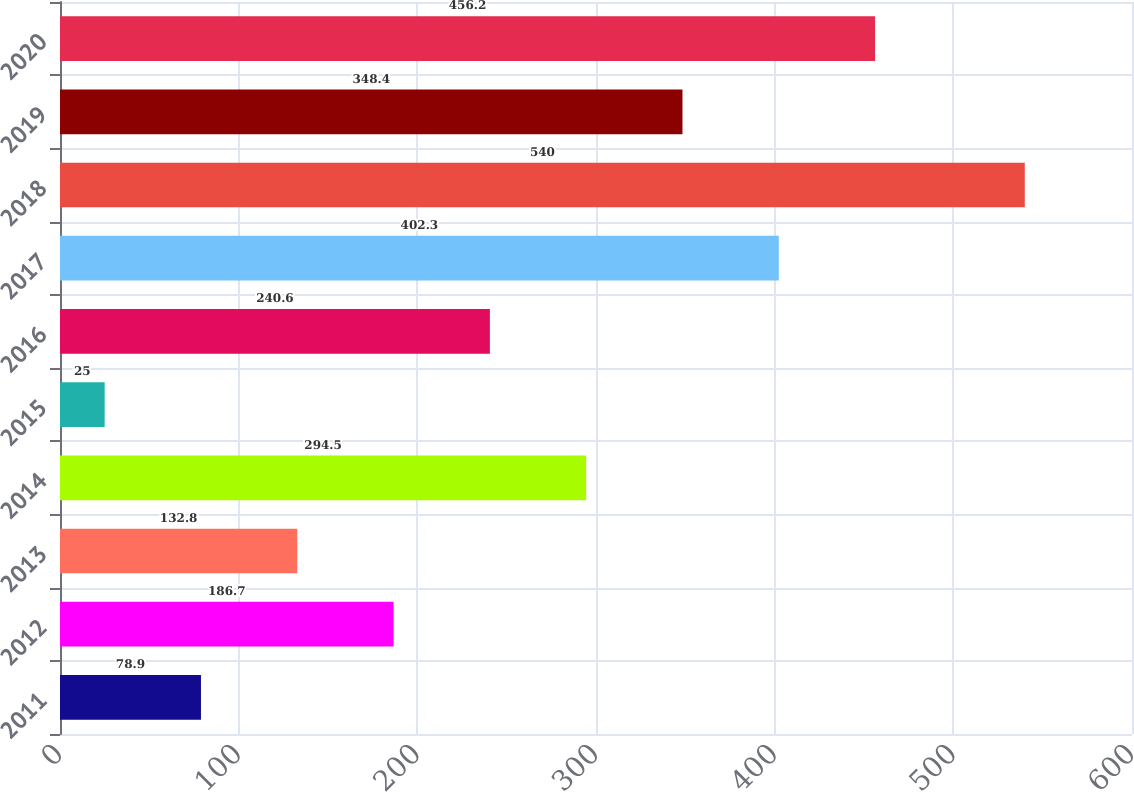<chart> <loc_0><loc_0><loc_500><loc_500><bar_chart><fcel>2011<fcel>2012<fcel>2013<fcel>2014<fcel>2015<fcel>2016<fcel>2017<fcel>2018<fcel>2019<fcel>2020<nl><fcel>78.9<fcel>186.7<fcel>132.8<fcel>294.5<fcel>25<fcel>240.6<fcel>402.3<fcel>540<fcel>348.4<fcel>456.2<nl></chart> 